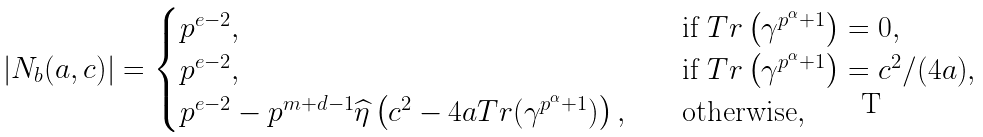Convert formula to latex. <formula><loc_0><loc_0><loc_500><loc_500>| N _ { b } ( a , c ) | = \begin{cases} p ^ { e - 2 } , & \quad \text {if} \ T r \left ( \gamma ^ { p ^ { \alpha } + 1 } \right ) = 0 , \\ p ^ { e - 2 } , & \quad \text {if} \ T r \left ( \gamma ^ { p ^ { \alpha } + 1 } \right ) = c ^ { 2 } / ( 4 a ) , \\ p ^ { e - 2 } - p ^ { m + d - 1 } \widehat { \eta } \left ( c ^ { 2 } - 4 a T r ( \gamma ^ { p ^ { \alpha } + 1 } ) \right ) , & \quad \text {otherwise} , \end{cases}</formula> 